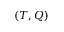<formula> <loc_0><loc_0><loc_500><loc_500>( T , Q )</formula> 